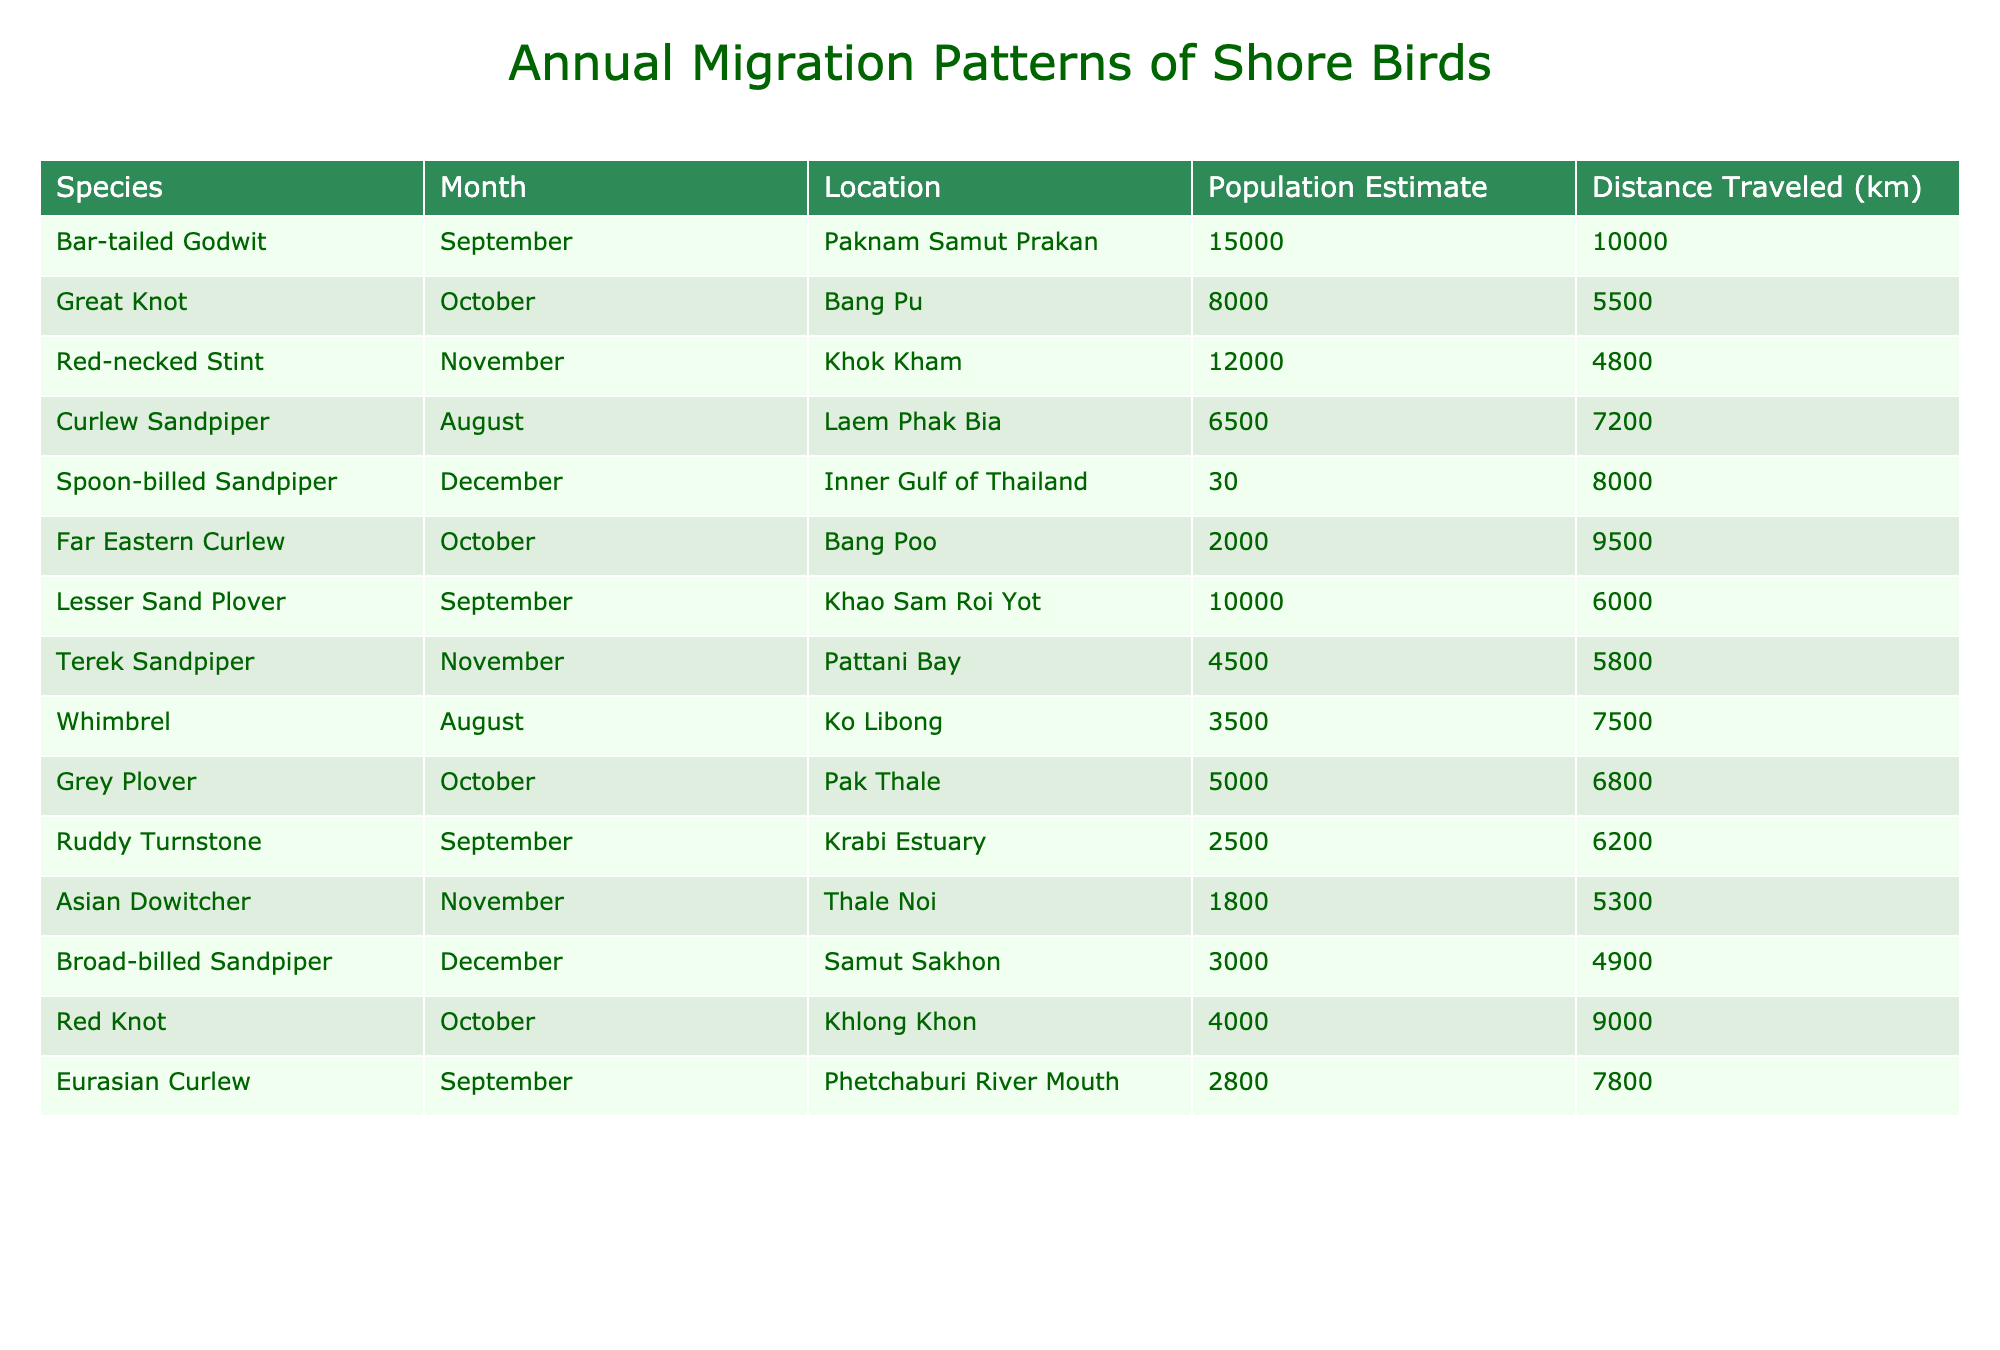What is the population estimate of the Spoon-billed Sandpiper? Looking at the table, the row for the Spoon-billed Sandpiper shows a population estimate of 30 in December.
Answer: 30 Which species has the highest population estimate in September? The table shows the population estimates for September: Bar-tailed Godwit (15000) and Lesser Sand Plover (10000). The highest is 15000 for the Bar-tailed Godwit.
Answer: Bar-tailed Godwit What is the average distance traveled by species in November? The distances for November are: Red-necked Stint (4800), Terek Sandpiper (5800), and Asian Dowitcher (5300). To find the average: (4800 + 5800 + 5300) / 3 = 5300.
Answer: 5300 Is the Great Knot migrating to a location in September? The table does not list any migration data for the Great Knot in September; it only has data for October. Therefore, the answer is no.
Answer: No What species traveled the longest distance in August? In August, the Whimbrel traveled 7500 km and the Curlew Sandpiper traveled 7200 km. The longest distance is 7500 km by the Whimbrel.
Answer: Whimbrel Which species has the lowest population estimate, and when do they migrate? The Spoon-billed Sandpiper has a population estimate of 30, which is the lowest, and it migrates in December.
Answer: Spoon-billed Sandpiper, December How many species migrated to Bang Poo, and what are their population estimates? The table shows that two species migrated to Bang Poo: Great Knot (8000) in October and Far Eastern Curlew (2000) in October. The population estimates are 8000 and 2000 respectively.
Answer: 2: 8000, 2000 What is the total population estimate of shore birds that migrate in December? In December, the populations are 30 (Spoon-billed Sandpiper) and 3000 (Broad-billed Sandpiper). Summing these gives 30 + 3000 = 3030.
Answer: 3030 Are there any species migrating in both September and October? The table lists migrations in September for Bar-tailed Godwit and Lesser Sand Plover, and in October for Great Knot and others. No species overlap in both months.
Answer: No Which species has the largest difference in population estimates between September and October? Comparing September and October population estimates, the Bar-tailed Godwit (15000) in September and Great Knot (8000) in October gives a difference of 7000. This is the largest difference noted.
Answer: 7000 